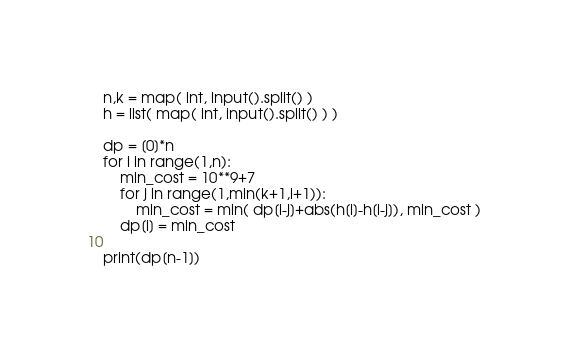<code> <loc_0><loc_0><loc_500><loc_500><_Python_>n,k = map( int, input().split() )
h = list( map( int, input().split() ) )

dp = [0]*n
for i in range(1,n):
    min_cost = 10**9+7
    for j in range(1,min(k+1,i+1)):
        min_cost = min( dp[i-j]+abs(h[i]-h[i-j]), min_cost )
    dp[i] = min_cost

print(dp[n-1])</code> 